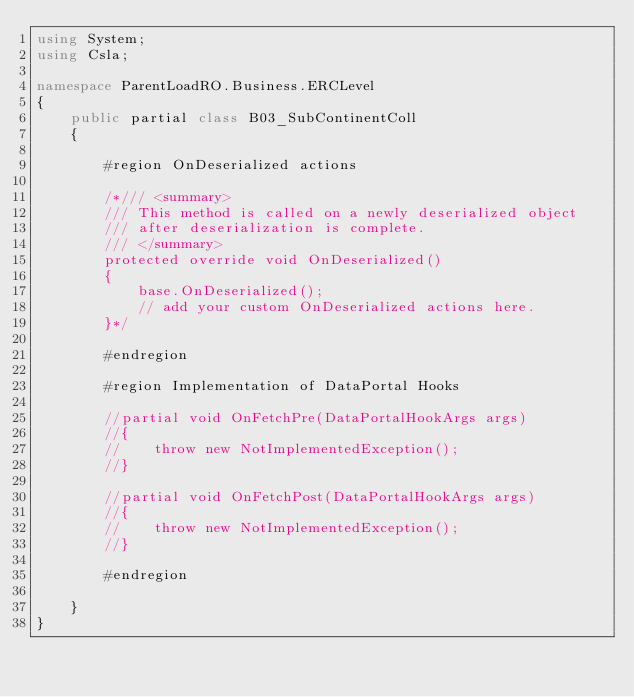<code> <loc_0><loc_0><loc_500><loc_500><_C#_>using System;
using Csla;

namespace ParentLoadRO.Business.ERCLevel
{
    public partial class B03_SubContinentColl
    {

        #region OnDeserialized actions

        /*/// <summary>
        /// This method is called on a newly deserialized object
        /// after deserialization is complete.
        /// </summary>
        protected override void OnDeserialized()
        {
            base.OnDeserialized();
            // add your custom OnDeserialized actions here.
        }*/

        #endregion

        #region Implementation of DataPortal Hooks

        //partial void OnFetchPre(DataPortalHookArgs args)
        //{
        //    throw new NotImplementedException();
        //}

        //partial void OnFetchPost(DataPortalHookArgs args)
        //{
        //    throw new NotImplementedException();
        //}

        #endregion

    }
}
</code> 